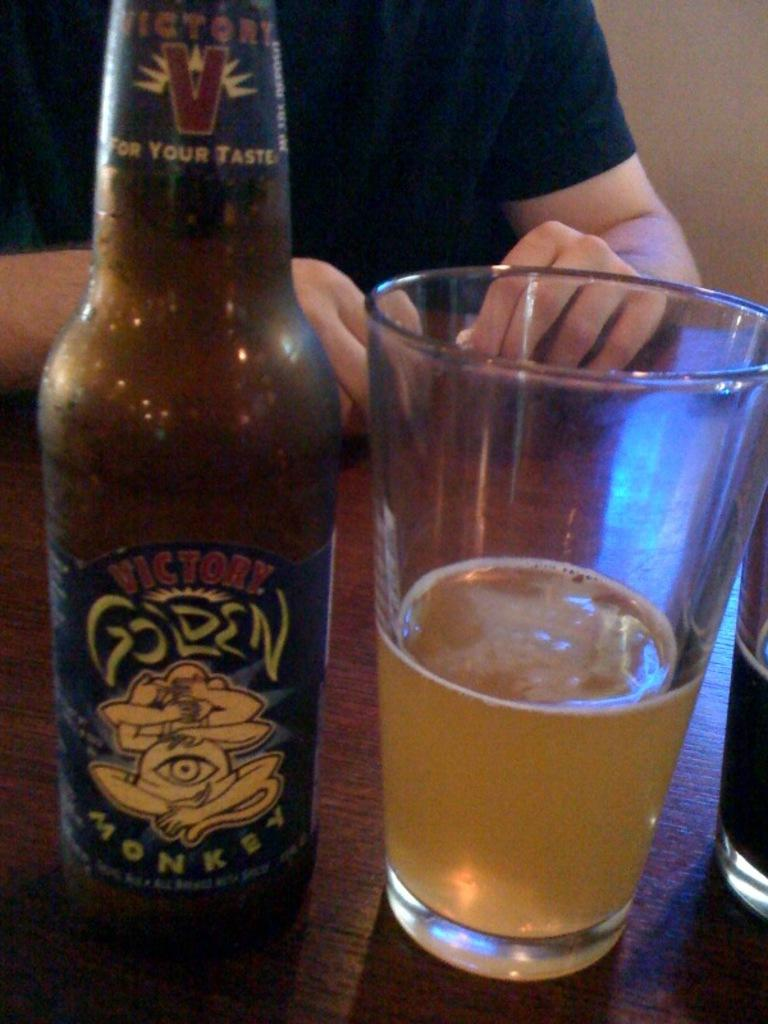<image>
Share a concise interpretation of the image provided. a bottle of victory golden monkey next to a glass filled of it 